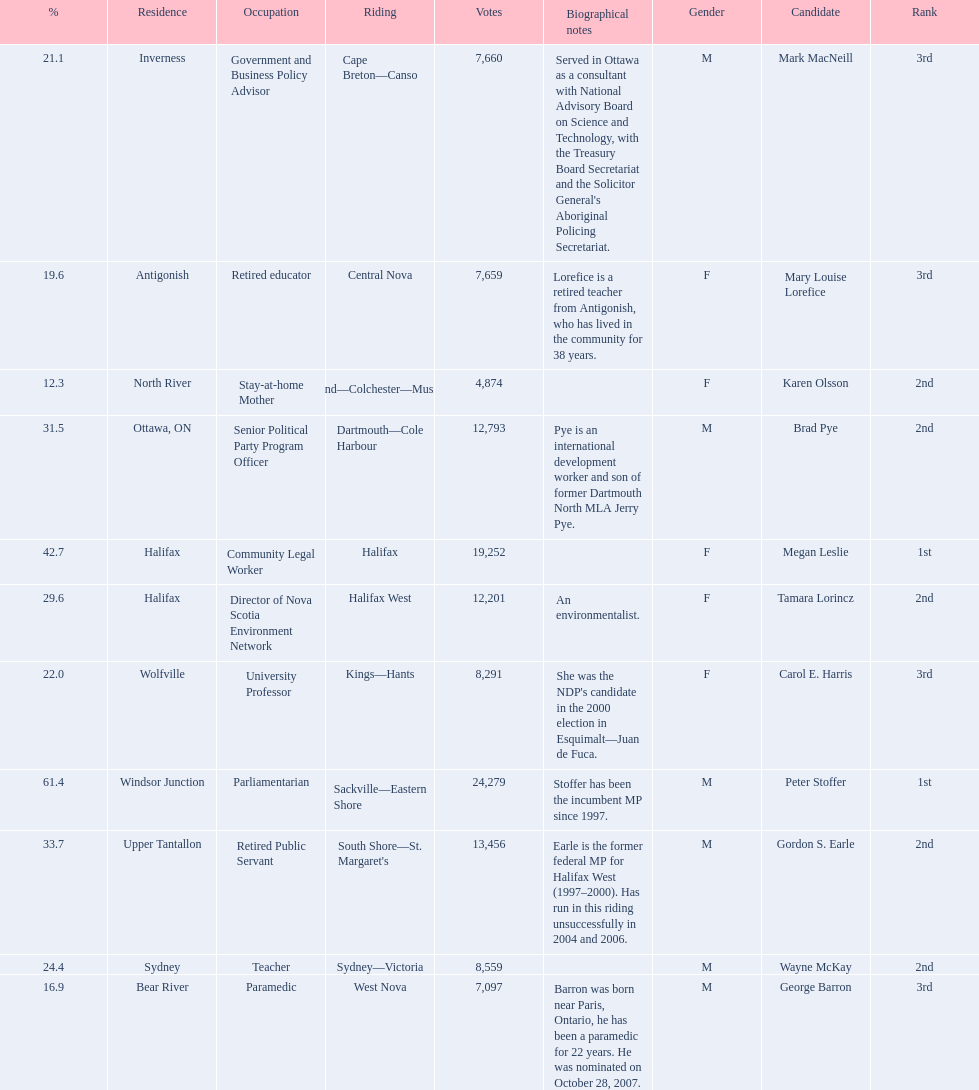Who were the new democratic party candidates, 2008? Mark MacNeill, Mary Louise Lorefice, Karen Olsson, Brad Pye, Megan Leslie, Tamara Lorincz, Carol E. Harris, Peter Stoffer, Gordon S. Earle, Wayne McKay, George Barron. Who had the 2nd highest number of votes? Megan Leslie, Peter Stoffer. How many votes did she receive? 19,252. 